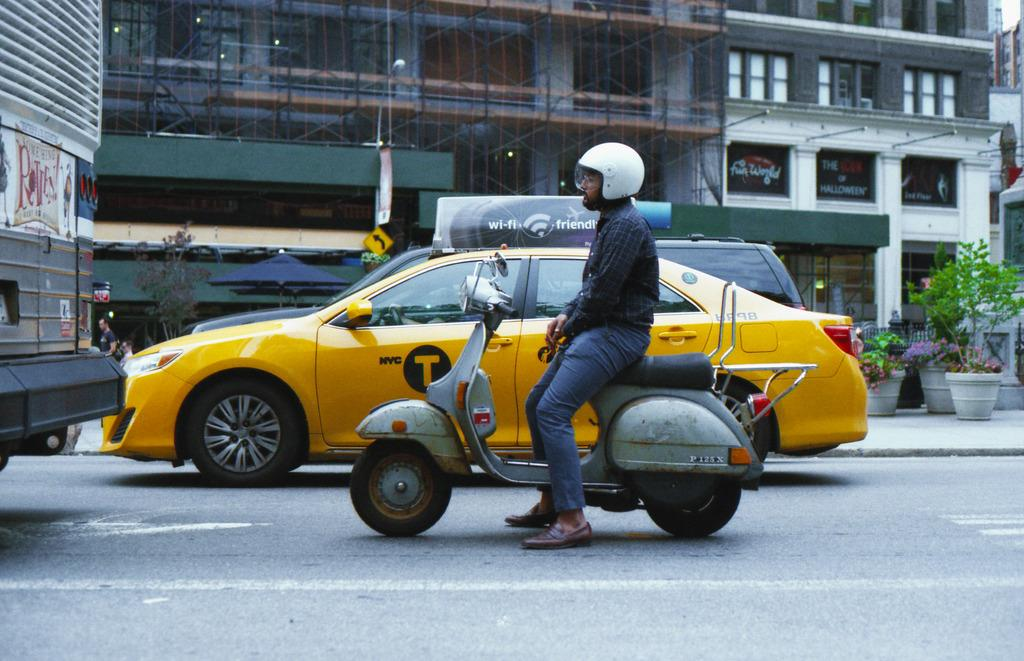<image>
Create a compact narrative representing the image presented. A yellow taxi with a T on its door idles in traffic next to a motorcycle. 